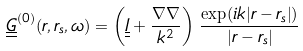Convert formula to latex. <formula><loc_0><loc_0><loc_500><loc_500>\underline { \underline { G } } ^ { ( 0 ) } ( r , r _ { s } , \omega ) = \left ( \underline { \underline { I } } + \frac { \nabla \nabla } { k ^ { 2 } } \right ) \, \frac { \exp ( { i k | r - r _ { s } | } ) } { | r - r _ { s } | }</formula> 